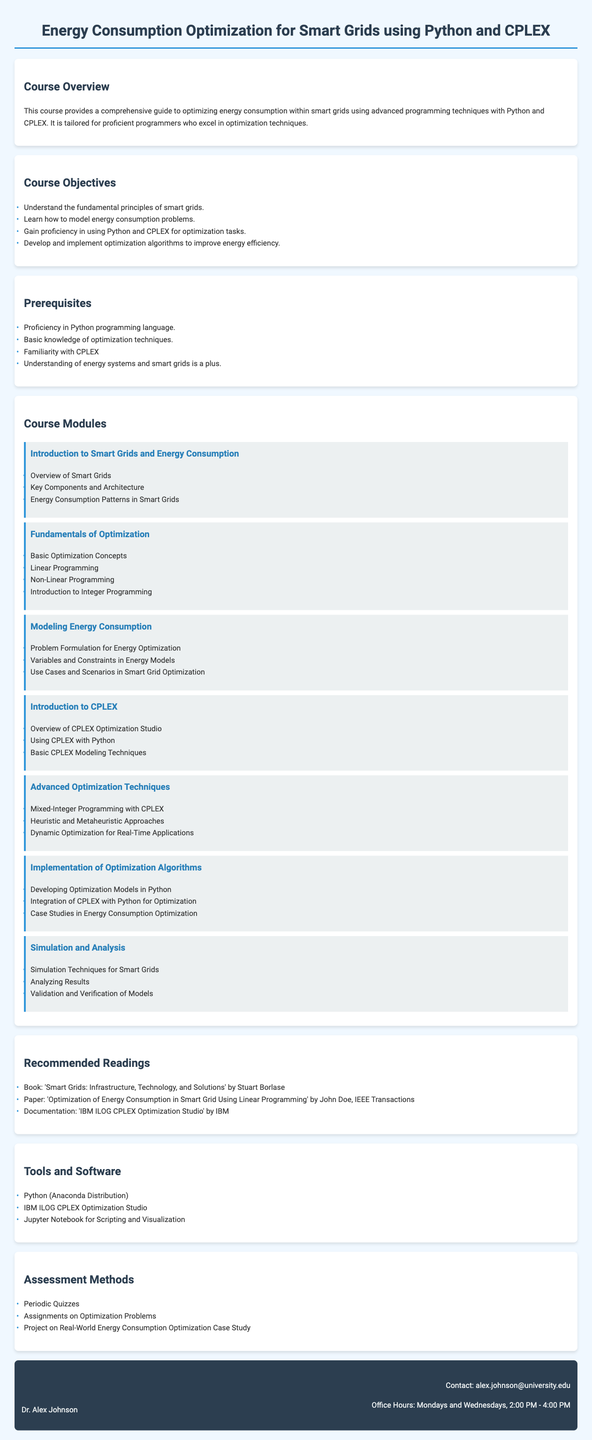What is the course title? The course title is typically provided at the top of the syllabus as the main heading.
Answer: Energy Consumption Optimization for Smart Grids using Python and CPLEX Who is the instructor? The instructor's name is located in the section dedicated to them, providing information on who will lead the course.
Answer: Dr. Alex Johnson What is one of the course objectives? Course objectives are listed as bullet points under the relevant section, indicating the goals for participants.
Answer: Understand the fundamental principles of smart grids What software is recommended for the course? The tools and software section lists essential programs for the course, which students are expected to use.
Answer: Python (Anaconda Distribution) How many modules are listed in the course? The number of modules can be counted in the course module section to determine how many topics will be covered.
Answer: Seven What is one prerequisite for the course? Prerequisites are specified to inform students of the knowledge and skills required before taking the course.
Answer: Proficiency in Python programming language What is the assessment method mentioned in the document? The assessment methods section lists various ways students will be evaluated throughout the course.
Answer: Project on Real-World Energy Consumption Optimization Case Study What is one advanced optimization technique discussed in the course? The course modules include specific techniques that students will learn about under advanced topics.
Answer: Mixed-Integer Programming with CPLEX What is the contact email for the instructor? Instructor contact information is provided, ensuring students know how to reach them for inquiries.
Answer: alex.johnson@university.edu 